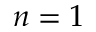Convert formula to latex. <formula><loc_0><loc_0><loc_500><loc_500>n = 1</formula> 